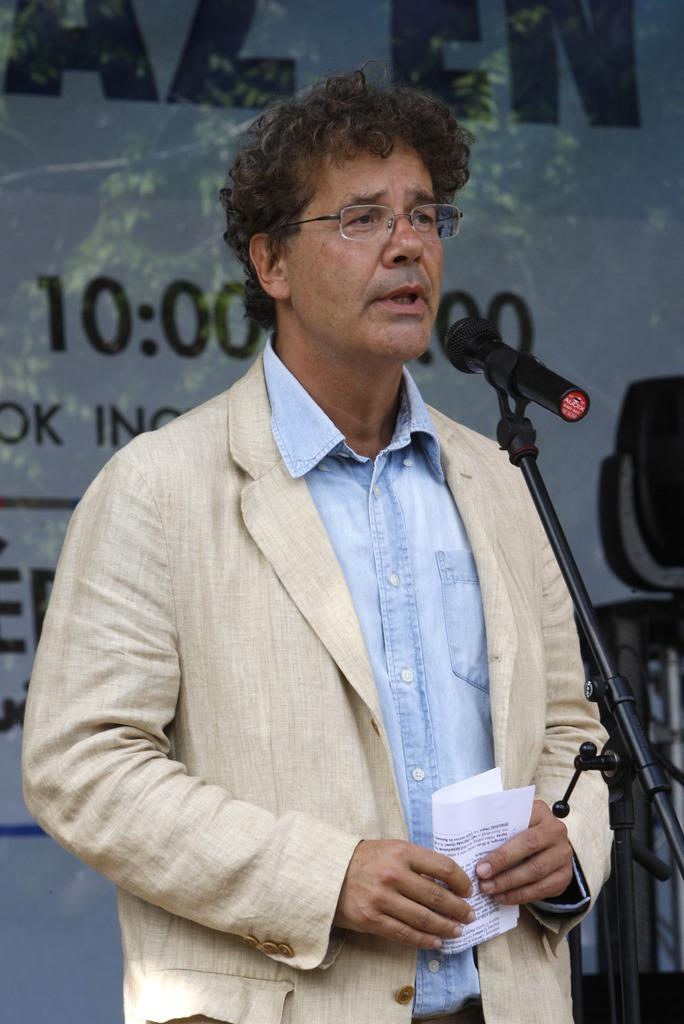Who is present in the image? There is a man in the image. What is the man doing in the image? The man is standing in the image. What is the man holding in the image? The man is holding a paper in the image. What object is in front of the man in the image? There is a microphone with a stand in front of the man in the image. What can be seen behind the man in the image? There is a banner behind the man in the image. What type of dinner is being served in the image? There is no dinner present in the image; it features a man standing with a paper, a microphone with a stand, and a banner. Is there a camp visible in the image? There is no camp present in the image; it features a man standing with a paper, a microphone with a stand, and a banner. 